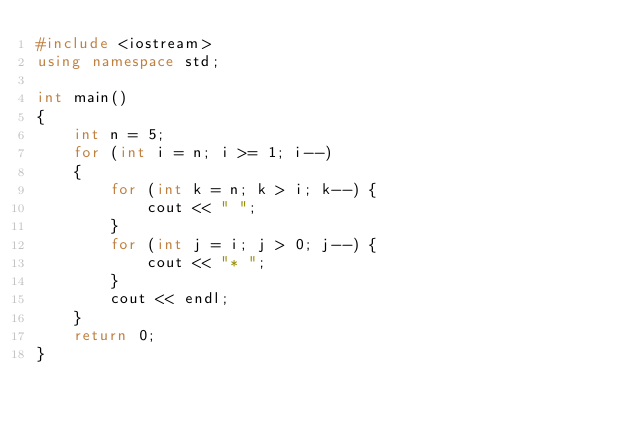Convert code to text. <code><loc_0><loc_0><loc_500><loc_500><_C++_>#include <iostream>
using namespace std;

int main()
{
    int n = 5;
    for (int i = n; i >= 1; i--)
    {
        for (int k = n; k > i; k--) {
            cout << " ";
        }
        for (int j = i; j > 0; j--) {
            cout << "* ";
        }
        cout << endl;
    }
    return 0;
}</code> 